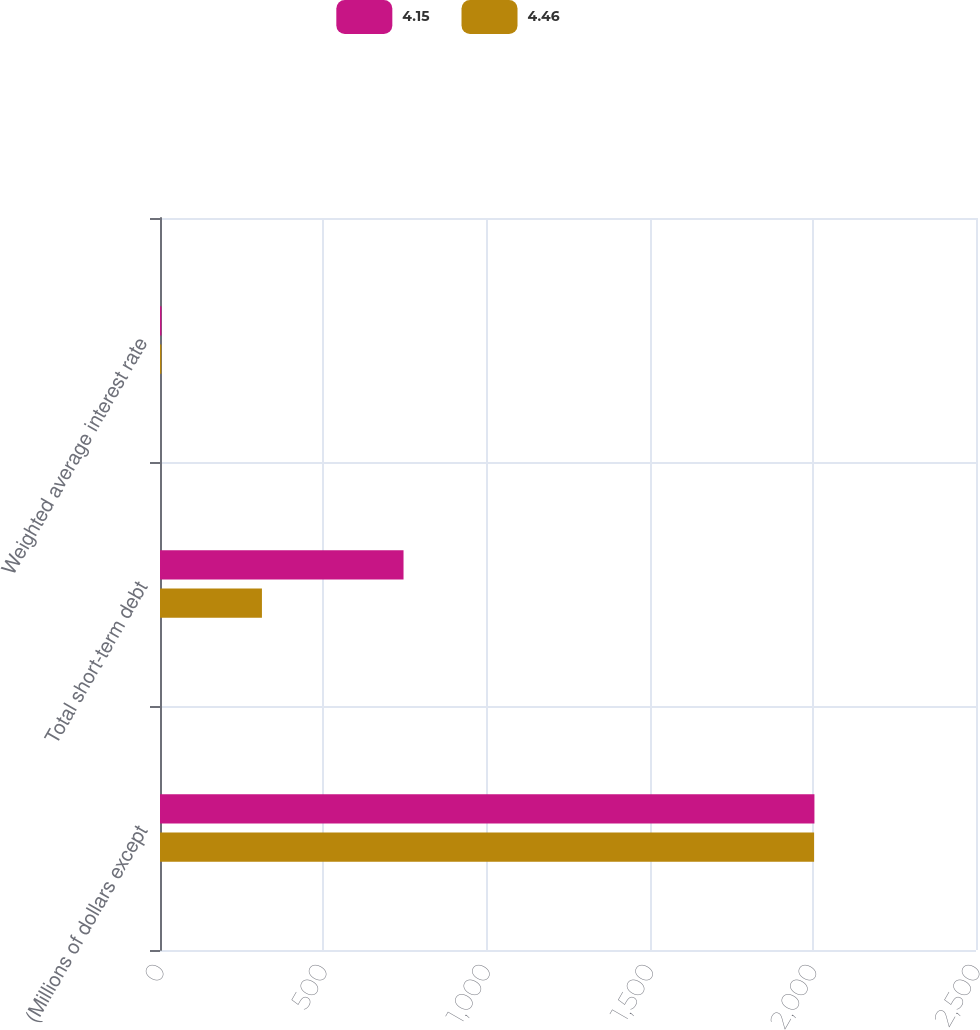Convert chart to OTSL. <chart><loc_0><loc_0><loc_500><loc_500><stacked_bar_chart><ecel><fcel>(Millions of dollars except<fcel>Total short-term debt<fcel>Weighted average interest rate<nl><fcel>4.15<fcel>2005<fcel>746.1<fcel>4.46<nl><fcel>4.46<fcel>2004<fcel>312.3<fcel>4.15<nl></chart> 